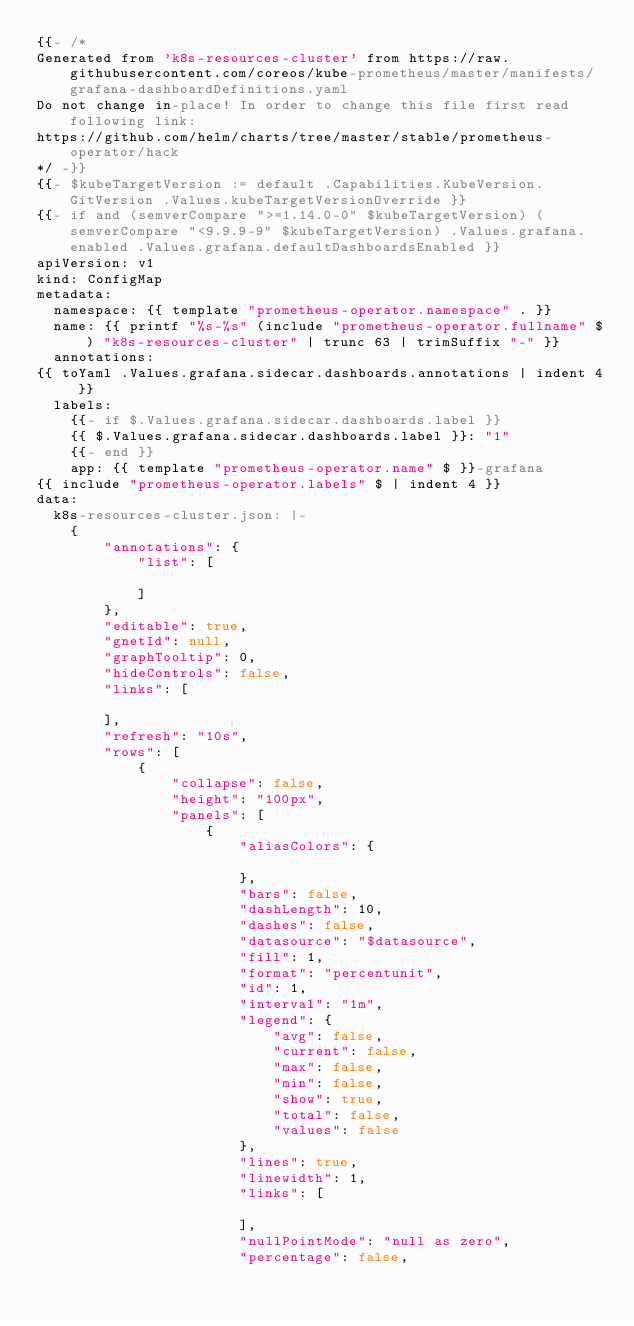<code> <loc_0><loc_0><loc_500><loc_500><_YAML_>{{- /*
Generated from 'k8s-resources-cluster' from https://raw.githubusercontent.com/coreos/kube-prometheus/master/manifests/grafana-dashboardDefinitions.yaml
Do not change in-place! In order to change this file first read following link:
https://github.com/helm/charts/tree/master/stable/prometheus-operator/hack
*/ -}}
{{- $kubeTargetVersion := default .Capabilities.KubeVersion.GitVersion .Values.kubeTargetVersionOverride }}
{{- if and (semverCompare ">=1.14.0-0" $kubeTargetVersion) (semverCompare "<9.9.9-9" $kubeTargetVersion) .Values.grafana.enabled .Values.grafana.defaultDashboardsEnabled }}
apiVersion: v1
kind: ConfigMap
metadata:
  namespace: {{ template "prometheus-operator.namespace" . }}
  name: {{ printf "%s-%s" (include "prometheus-operator.fullname" $) "k8s-resources-cluster" | trunc 63 | trimSuffix "-" }}
  annotations:
{{ toYaml .Values.grafana.sidecar.dashboards.annotations | indent 4 }}
  labels:
    {{- if $.Values.grafana.sidecar.dashboards.label }}
    {{ $.Values.grafana.sidecar.dashboards.label }}: "1"
    {{- end }}
    app: {{ template "prometheus-operator.name" $ }}-grafana
{{ include "prometheus-operator.labels" $ | indent 4 }}
data:
  k8s-resources-cluster.json: |-
    {
        "annotations": {
            "list": [

            ]
        },
        "editable": true,
        "gnetId": null,
        "graphTooltip": 0,
        "hideControls": false,
        "links": [

        ],
        "refresh": "10s",
        "rows": [
            {
                "collapse": false,
                "height": "100px",
                "panels": [
                    {
                        "aliasColors": {

                        },
                        "bars": false,
                        "dashLength": 10,
                        "dashes": false,
                        "datasource": "$datasource",
                        "fill": 1,
                        "format": "percentunit",
                        "id": 1,
                        "interval": "1m",
                        "legend": {
                            "avg": false,
                            "current": false,
                            "max": false,
                            "min": false,
                            "show": true,
                            "total": false,
                            "values": false
                        },
                        "lines": true,
                        "linewidth": 1,
                        "links": [

                        ],
                        "nullPointMode": "null as zero",
                        "percentage": false,</code> 